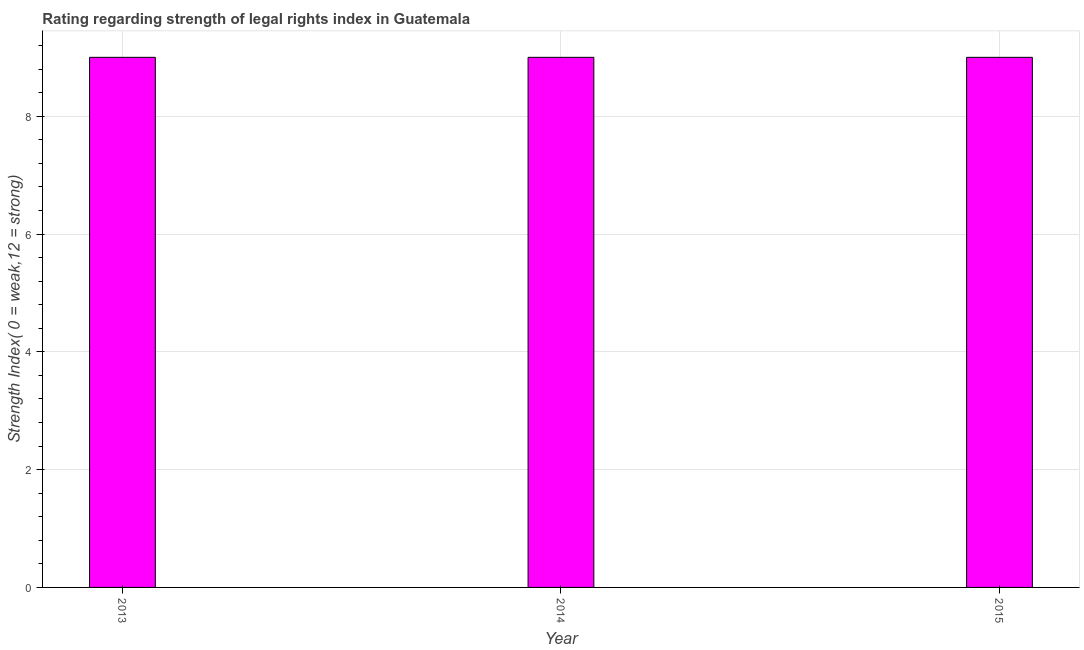Does the graph contain any zero values?
Offer a terse response. No. Does the graph contain grids?
Make the answer very short. Yes. What is the title of the graph?
Your answer should be compact. Rating regarding strength of legal rights index in Guatemala. What is the label or title of the Y-axis?
Offer a very short reply. Strength Index( 0 = weak,12 = strong). Across all years, what is the minimum strength of legal rights index?
Your response must be concise. 9. In which year was the strength of legal rights index maximum?
Ensure brevity in your answer.  2013. What is the average strength of legal rights index per year?
Your answer should be compact. 9. Do a majority of the years between 2015 and 2013 (inclusive) have strength of legal rights index greater than 3.2 ?
Provide a succinct answer. Yes. What is the ratio of the strength of legal rights index in 2013 to that in 2015?
Keep it short and to the point. 1. Is the difference between the strength of legal rights index in 2013 and 2015 greater than the difference between any two years?
Ensure brevity in your answer.  Yes. In how many years, is the strength of legal rights index greater than the average strength of legal rights index taken over all years?
Your response must be concise. 0. Are the values on the major ticks of Y-axis written in scientific E-notation?
Your answer should be compact. No. What is the Strength Index( 0 = weak,12 = strong) of 2013?
Offer a terse response. 9. What is the difference between the Strength Index( 0 = weak,12 = strong) in 2013 and 2014?
Provide a short and direct response. 0. What is the difference between the Strength Index( 0 = weak,12 = strong) in 2014 and 2015?
Provide a succinct answer. 0. What is the ratio of the Strength Index( 0 = weak,12 = strong) in 2013 to that in 2014?
Provide a succinct answer. 1. What is the ratio of the Strength Index( 0 = weak,12 = strong) in 2013 to that in 2015?
Make the answer very short. 1. 